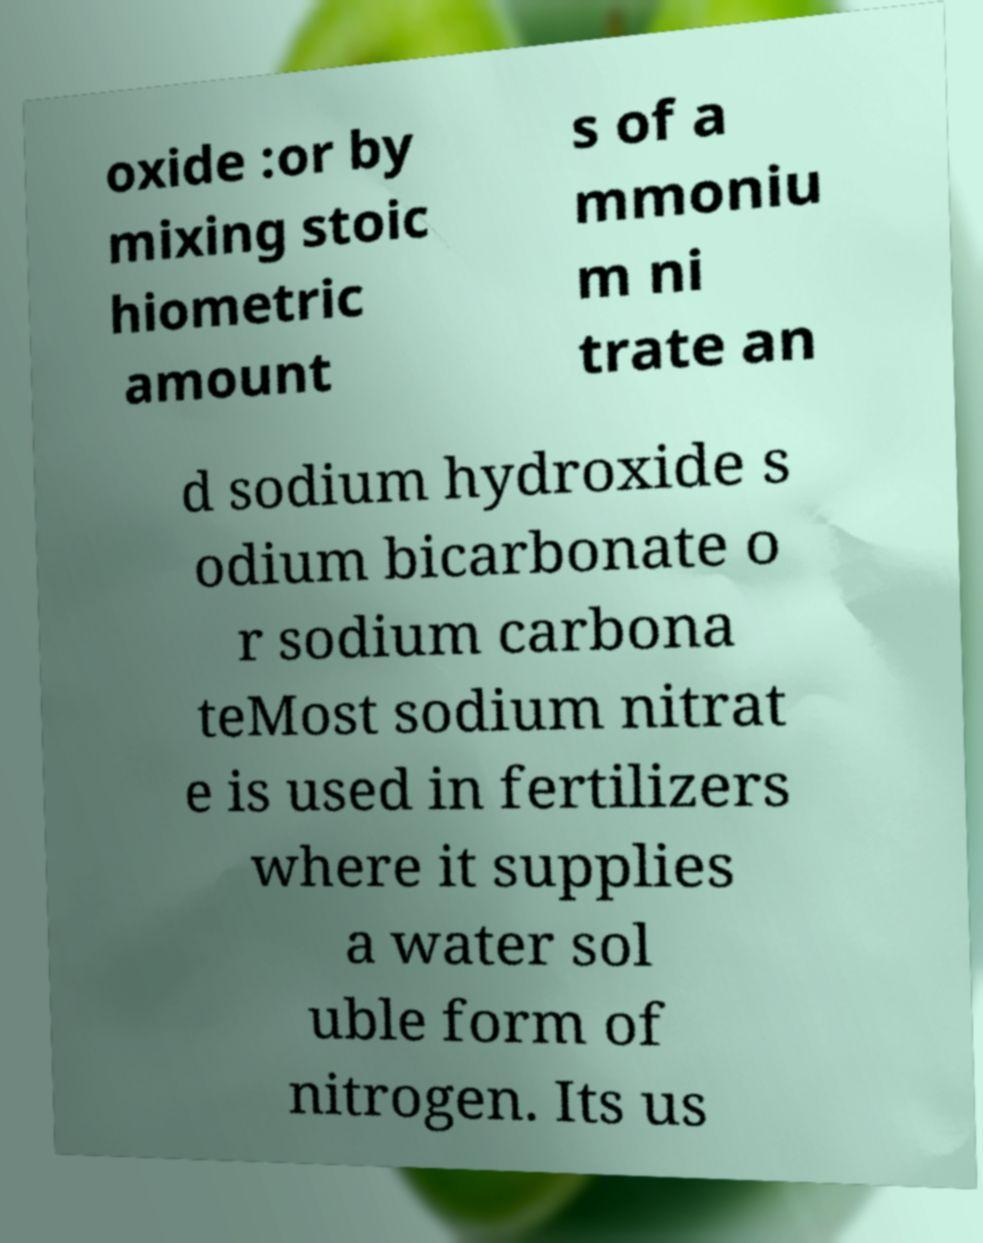Could you assist in decoding the text presented in this image and type it out clearly? oxide :or by mixing stoic hiometric amount s of a mmoniu m ni trate an d sodium hydroxide s odium bicarbonate o r sodium carbona teMost sodium nitrat e is used in fertilizers where it supplies a water sol uble form of nitrogen. Its us 